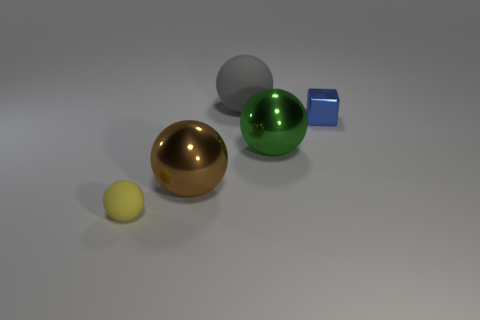Subtract 1 balls. How many balls are left? 3 Add 1 tiny rubber spheres. How many objects exist? 6 Subtract all spheres. How many objects are left? 1 Add 5 brown metal things. How many brown metal things are left? 6 Add 1 tiny balls. How many tiny balls exist? 2 Subtract 0 gray cylinders. How many objects are left? 5 Subtract all big blue matte balls. Subtract all big gray rubber objects. How many objects are left? 4 